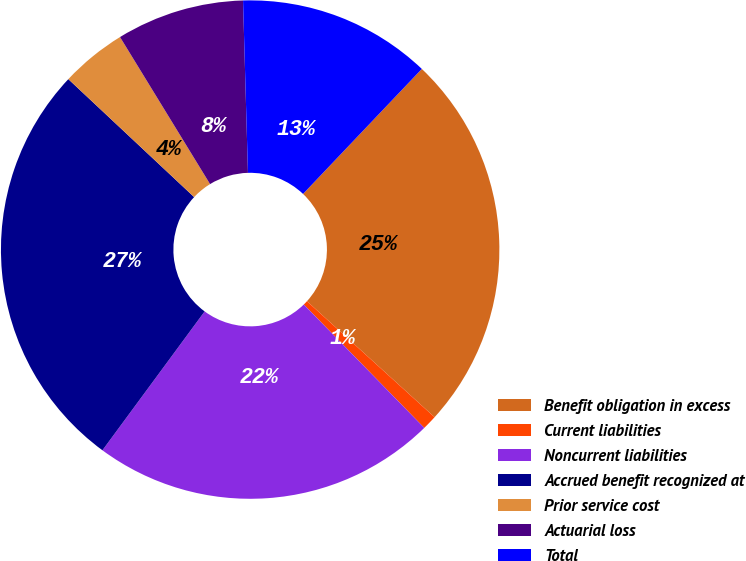Convert chart. <chart><loc_0><loc_0><loc_500><loc_500><pie_chart><fcel>Benefit obligation in excess<fcel>Current liabilities<fcel>Noncurrent liabilities<fcel>Accrued benefit recognized at<fcel>Prior service cost<fcel>Actuarial loss<fcel>Total<nl><fcel>24.65%<fcel>0.95%<fcel>22.41%<fcel>26.89%<fcel>4.27%<fcel>8.29%<fcel>12.55%<nl></chart> 